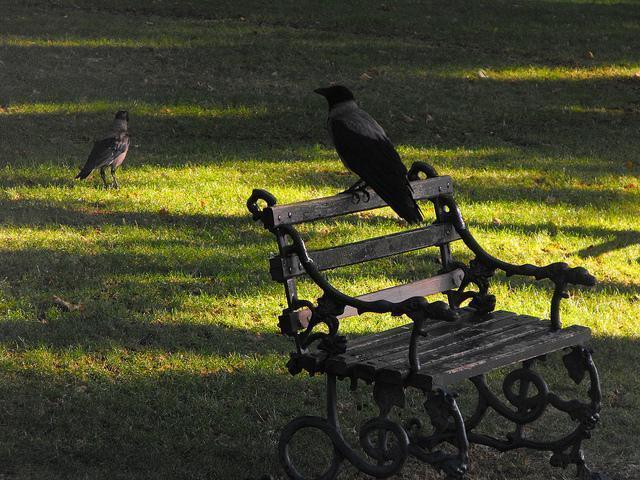How many adults would comfortably fit on this bench?
Give a very brief answer. 1. How many birds are in the picture?
Give a very brief answer. 2. How many birds are visible?
Give a very brief answer. 2. 